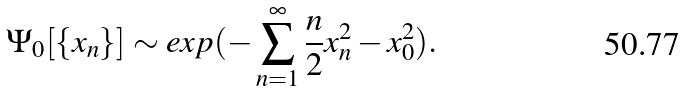Convert formula to latex. <formula><loc_0><loc_0><loc_500><loc_500>\Psi _ { 0 } [ \{ x _ { n } \} ] \sim e x p ( - \sum _ { n = 1 } ^ { \infty } \frac { n } { 2 } x _ { n } ^ { 2 } - x _ { 0 } ^ { 2 } ) .</formula> 